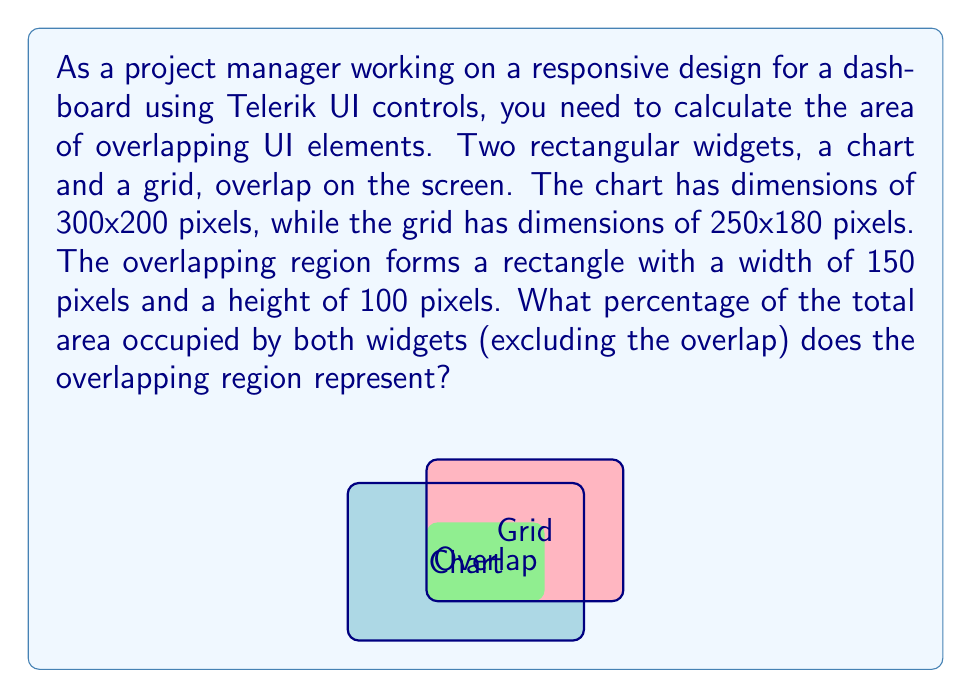Can you solve this math problem? Let's approach this step-by-step:

1. Calculate the area of the chart:
   $A_{chart} = 300 \times 200 = 60,000$ square pixels

2. Calculate the area of the grid:
   $A_{grid} = 250 \times 180 = 45,000$ square pixels

3. Calculate the area of the overlapping region:
   $A_{overlap} = 150 \times 100 = 15,000$ square pixels

4. Calculate the total area occupied by both widgets, excluding the overlap:
   $A_{total} = A_{chart} + A_{grid} - A_{overlap}$
   $A_{total} = 60,000 + 45,000 - 15,000 = 90,000$ square pixels

5. Calculate the percentage of the overlapping area relative to the total area:
   $Percentage = \frac{A_{overlap}}{A_{total}} \times 100\%$
   $Percentage = \frac{15,000}{90,000} \times 100\% = \frac{1}{6} \times 100\% = 16.67\%$

Therefore, the overlapping region represents approximately 16.67% of the total area occupied by both widgets.
Answer: $16.67\%$ 